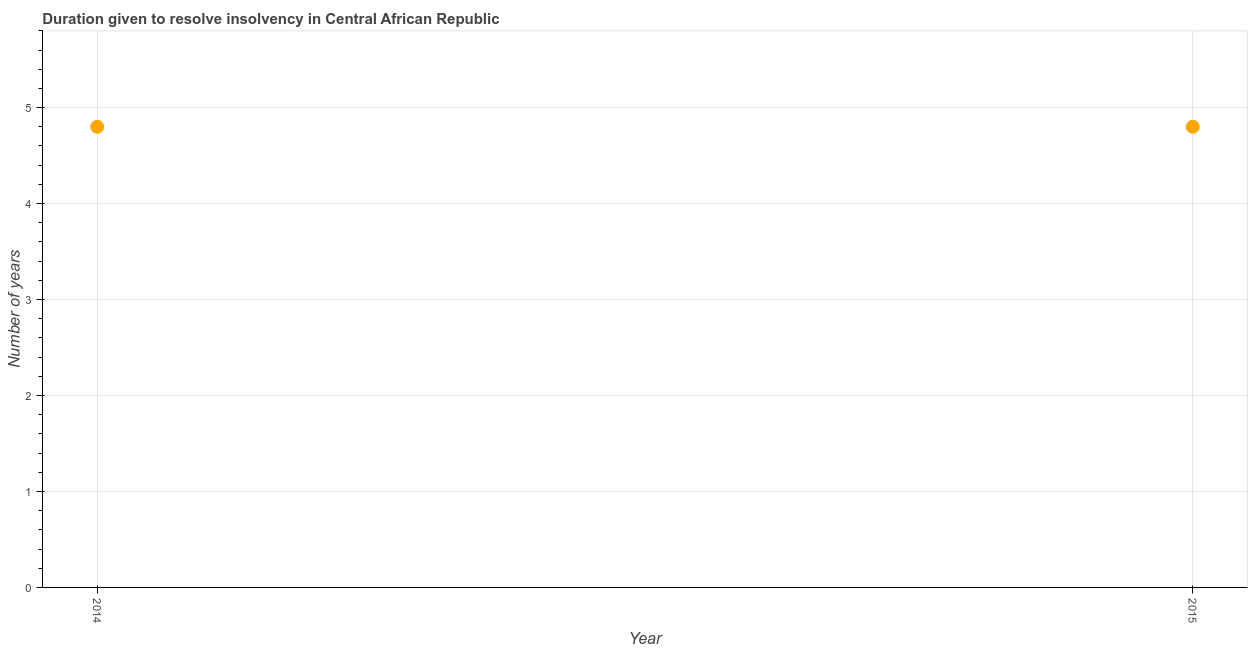What is the number of years to resolve insolvency in 2015?
Keep it short and to the point. 4.8. Across all years, what is the maximum number of years to resolve insolvency?
Your answer should be compact. 4.8. Across all years, what is the minimum number of years to resolve insolvency?
Give a very brief answer. 4.8. In which year was the number of years to resolve insolvency maximum?
Your answer should be compact. 2014. In which year was the number of years to resolve insolvency minimum?
Offer a very short reply. 2014. What is the average number of years to resolve insolvency per year?
Offer a very short reply. 4.8. What is the median number of years to resolve insolvency?
Keep it short and to the point. 4.8. In how many years, is the number of years to resolve insolvency greater than 5.2 ?
Keep it short and to the point. 0. Does the number of years to resolve insolvency monotonically increase over the years?
Provide a succinct answer. No. Are the values on the major ticks of Y-axis written in scientific E-notation?
Ensure brevity in your answer.  No. Does the graph contain any zero values?
Keep it short and to the point. No. Does the graph contain grids?
Your answer should be compact. Yes. What is the title of the graph?
Make the answer very short. Duration given to resolve insolvency in Central African Republic. What is the label or title of the Y-axis?
Provide a short and direct response. Number of years. What is the difference between the Number of years in 2014 and 2015?
Offer a very short reply. 0. 